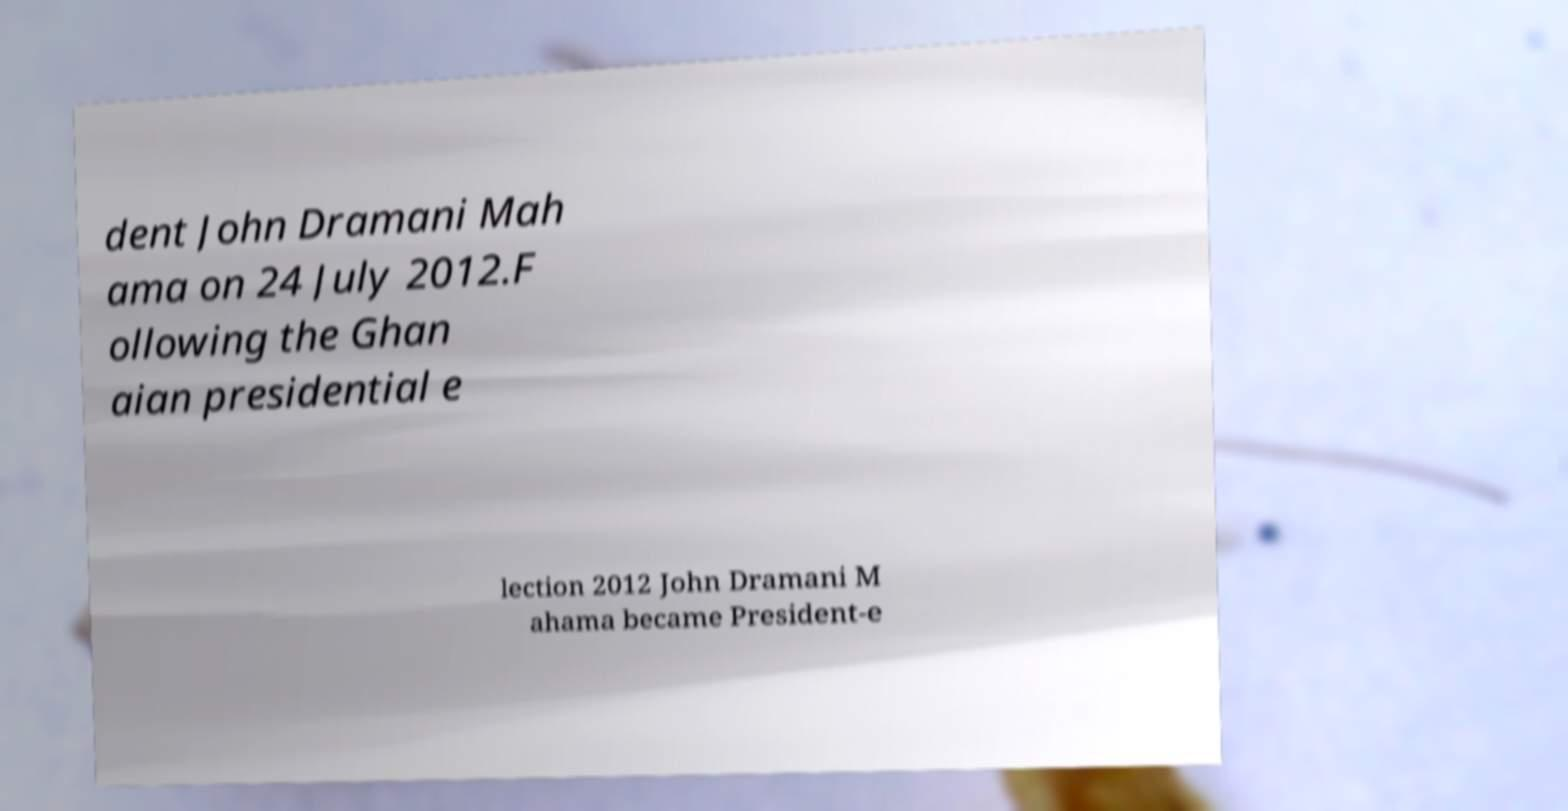Could you assist in decoding the text presented in this image and type it out clearly? dent John Dramani Mah ama on 24 July 2012.F ollowing the Ghan aian presidential e lection 2012 John Dramani M ahama became President-e 